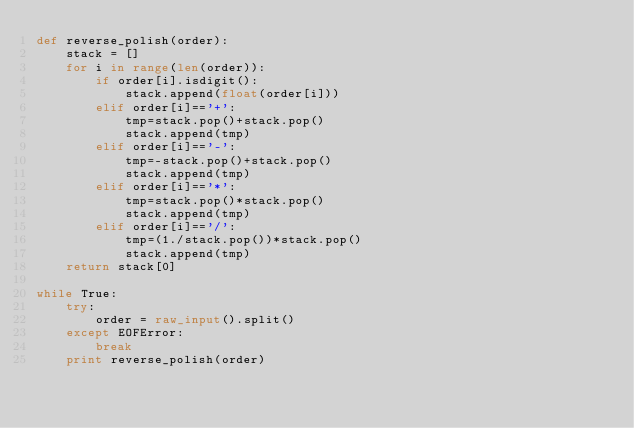<code> <loc_0><loc_0><loc_500><loc_500><_Python_>def reverse_polish(order):
    stack = []
    for i in range(len(order)):
        if order[i].isdigit():
            stack.append(float(order[i]))
        elif order[i]=='+':
            tmp=stack.pop()+stack.pop()
            stack.append(tmp)
        elif order[i]=='-':
            tmp=-stack.pop()+stack.pop()
            stack.append(tmp)
        elif order[i]=='*':
            tmp=stack.pop()*stack.pop()
            stack.append(tmp)
        elif order[i]=='/':            
            tmp=(1./stack.pop())*stack.pop()
            stack.append(tmp)
    return stack[0]

while True:
    try:
        order = raw_input().split()
    except EOFError: 
        break
    print reverse_polish(order)
    </code> 